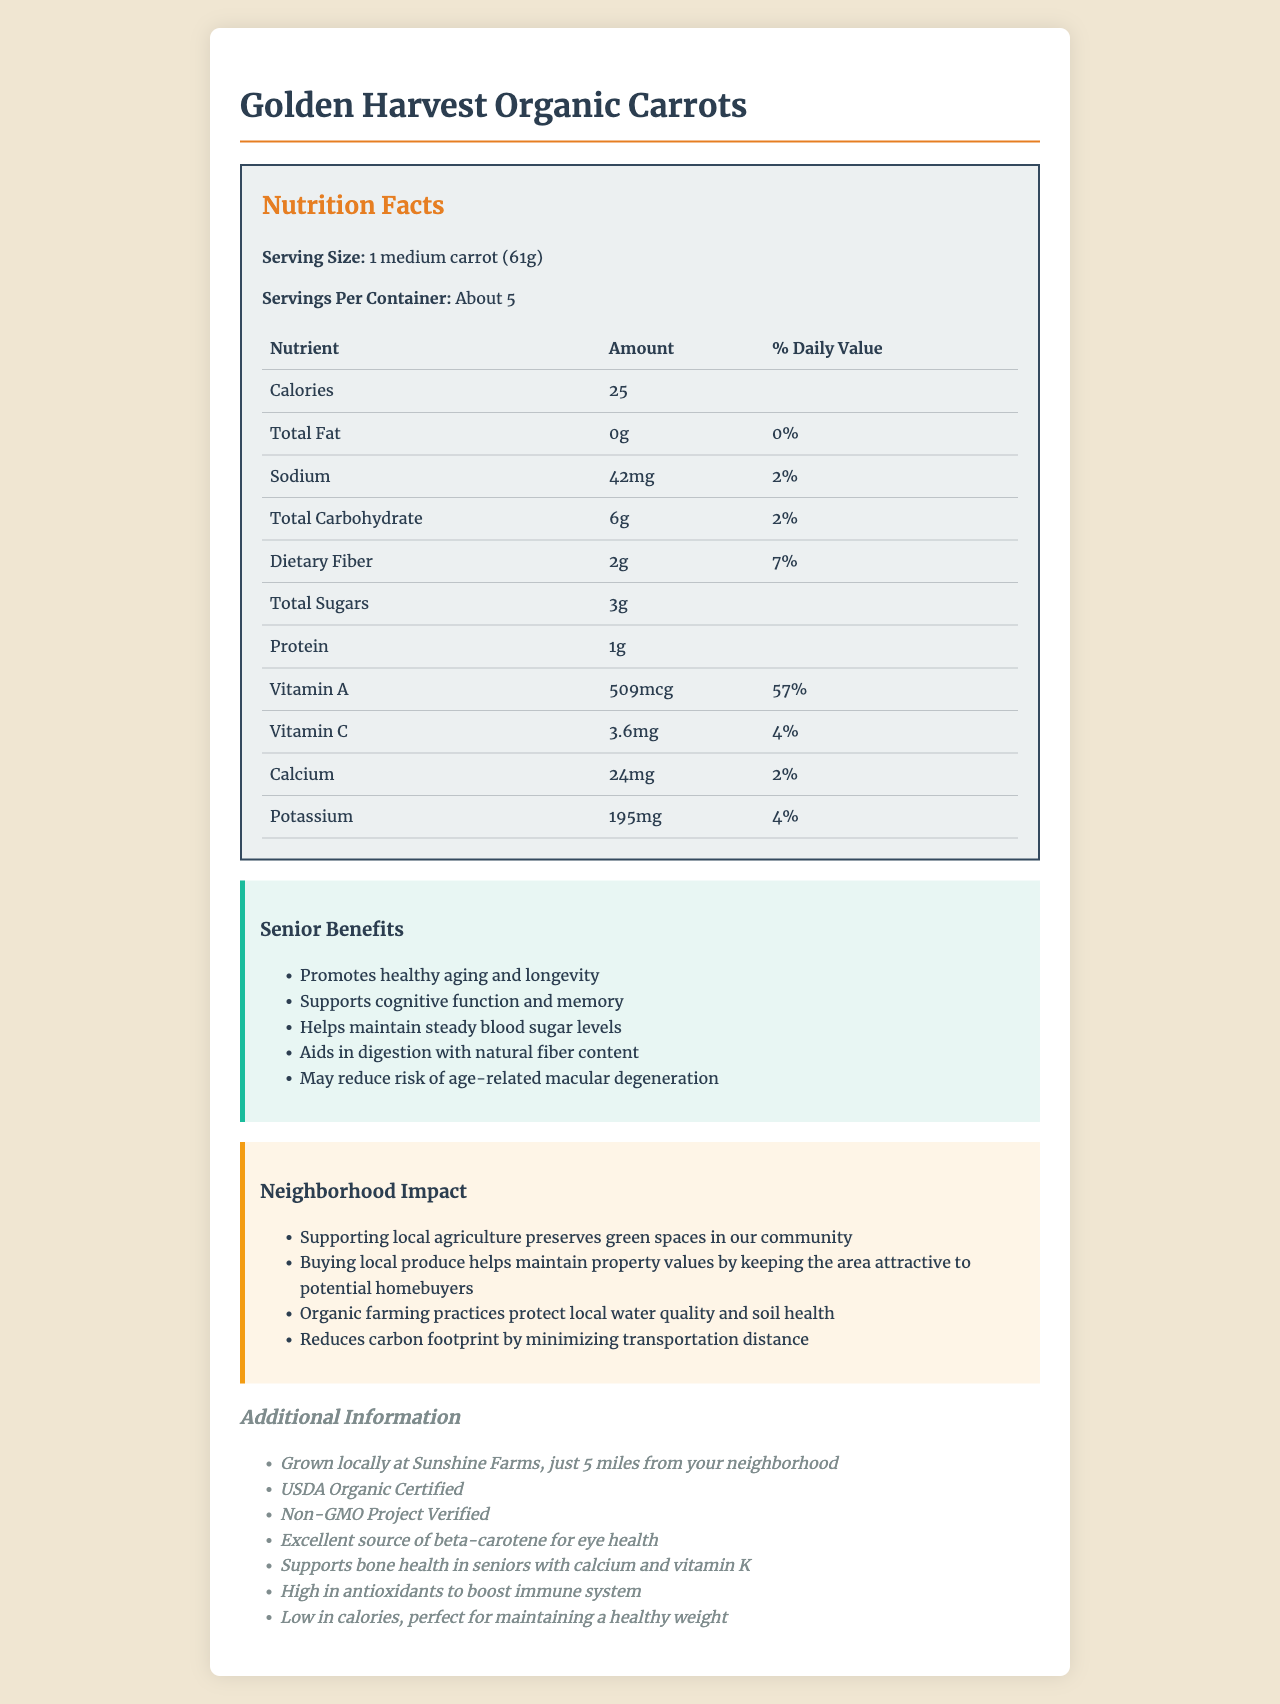What is the serving size of Golden Harvest Organic Carrots? The serving size is specified in the Nutrition Facts section as "1 medium carrot (61g)."
Answer: 1 medium carrot (61g) How many calories are in a serving of Golden Harvest Organic Carrots? The document states that there are 25 calories per serving.
Answer: 25 What is the % Daily Value of Vitamin A per serving? Under the Vitamin A section in the Nutrition Facts, the % Daily Value is listed as 57%.
Answer: 57% Which nutrient helps support bone health in seniors? The additional info section mentions that calcium and vitamin K support bone health in seniors.
Answer: Calcium and Vitamin K How much sodium is in one serving of Golden Harvest Organic Carrots? The sodium content is listed as 42mg per serving in the Nutrition Facts table.
Answer: 42mg Which nutrient is highest in terms of % Daily Value in this product? A. Vitamin A B. Vitamin C C. Calcium D. Dietary Fiber The % Daily Value of Vitamin A is 57%, which is the highest among the listed nutrients.
Answer: A. Vitamin A What is the total carbohydrate content per serving? A. 6g B. 2g C. 3g D. 1g The total carbohydrate content is listed as 6g per serving in the Nutrition Facts table.
Answer: A. 6g Is this product certified organic by USDA? Under additional info, it states that the product is USDA Organic Certified.
Answer: Yes Does buying locally sourced produce like Golden Harvest Organic Carrots help maintain property values? The neighborhood impact section mentions that buying local produce helps maintain property values by keeping the area attractive to potential homebuyers.
Answer: Yes Summarize the main benefits of Golden Harvest Organic Carrots for seniors. The senior benefits section lists these specific benefits that cater to the health needs of seniors.
Answer: Promotes healthy aging and longevity, supports cognitive function and memory, helps maintain steady blood sugar levels, aids in digestion with natural fiber content, may reduce risk of age-related macular degeneration. Where is Sunshine Farms located? The document states that the produce is grown locally at Sunshine Farms but does not provide a specific location.
Answer: Cannot be determined 